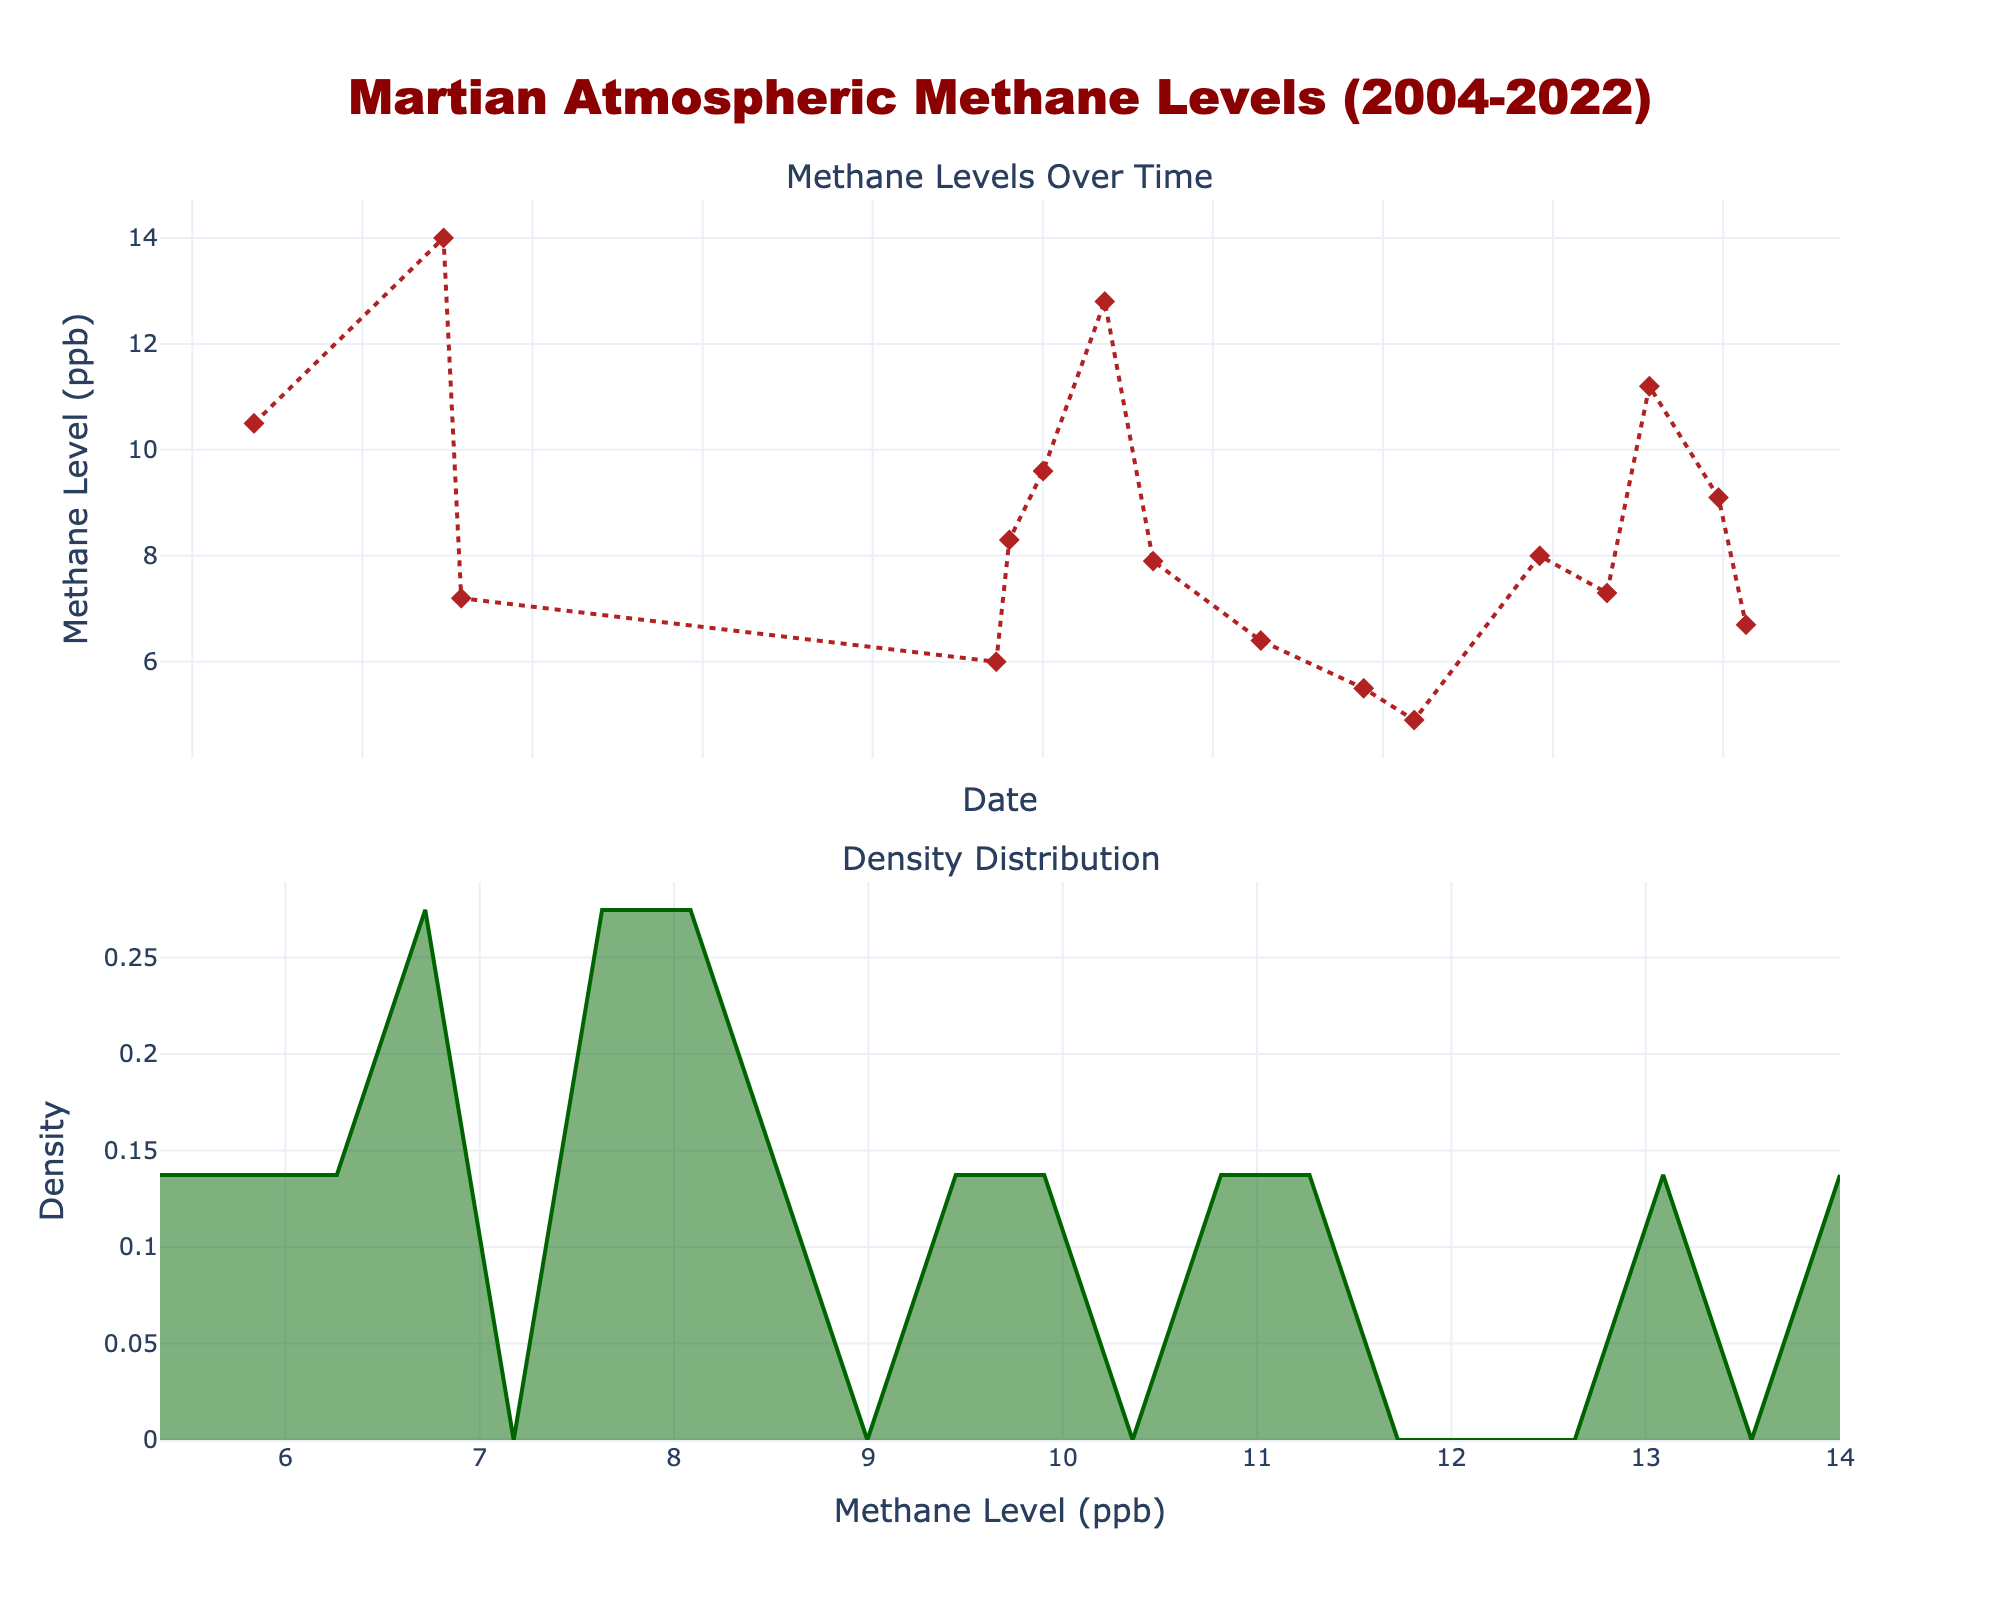what's the title of the figure? The title of the figure is found at the top and describes the overall topic of the plot.
Answer: Martian Atmospheric Methane Levels (2004-2022) how many total data points are represented in the scatter plot? Each point represents a methane level measurement on a specific date. Count the total number of points.
Answer: 16 what is the range of dates shown on the x-axis in the scatter plot? The x-axis shows the timeline over which methane measurements were taken. Identify the earliest and latest dates.
Answer: From 2004 to 2022 what is the highest methane level recorded according to the scatter plot? Find the point with the maximum methane level (in ppb) on the scatter plot.
Answer: 14.0 ppb which year has the most number of recorded methane measurements? Count the number of data points that fall within each year and identify the year with the highest count.
Answer: 2021 what's the median methane level of the data presented? To find the median, list all methane levels in ascending order and pick the middle value. If the number of values is even, average the two middle ones.
Answer: 7.9 ppb how do the methane levels in 2004 compare to those in 2022? Compare the methane level readings of these two specific years to see if one is higher, lower, or if they are equal.
Answer: 2004 has higher methane levels what is the overall trend observed in methane levels from 2004 to 2022? Look at the scatter plot and observe the slope of the lines connecting the data points. Determine if the values as a whole are increasing, decreasing, or stable.
Answer: Decreasing trend what can be inferred from the density distribution plot? Analyze the shape and spread of the density plot to infer the distribution of methane levels.
Answer: Most values are between 5 and 10 ppb which area has the highest density according to the density plot? Identify the peak of the density plot to find the methane level range with the highest density.
Answer: Around 7-8 ppb 